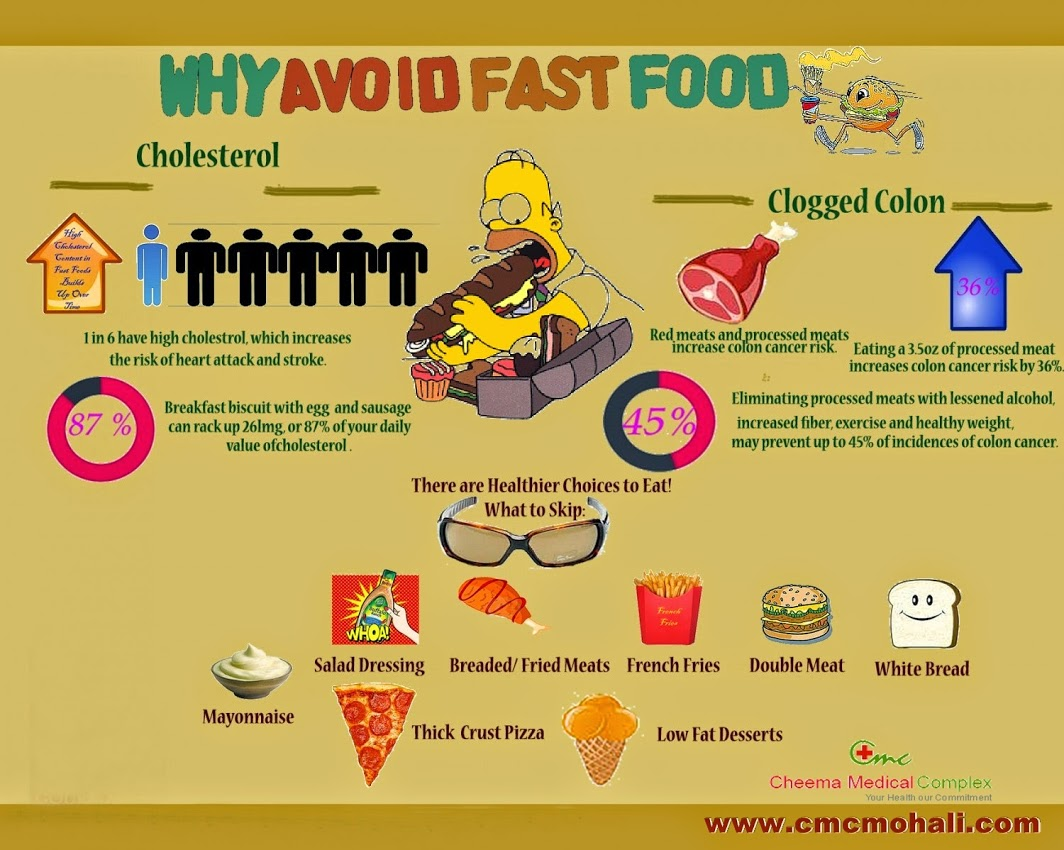What is the percentage decrease in the risk of colon cancer if processed meats are eliminated and other healthy habits are adopted, according to the infographic? According to the infographic, eliminating processed meats along with adopting other healthy habits like reducing alcohol consumption, increasing fiber intake, exercising, and maintaining a healthy weight can potentially reduce the incidences of colon cancer by up to 45%. This comprehensive approach significantly lowers the risk and promotes overall well-being. 